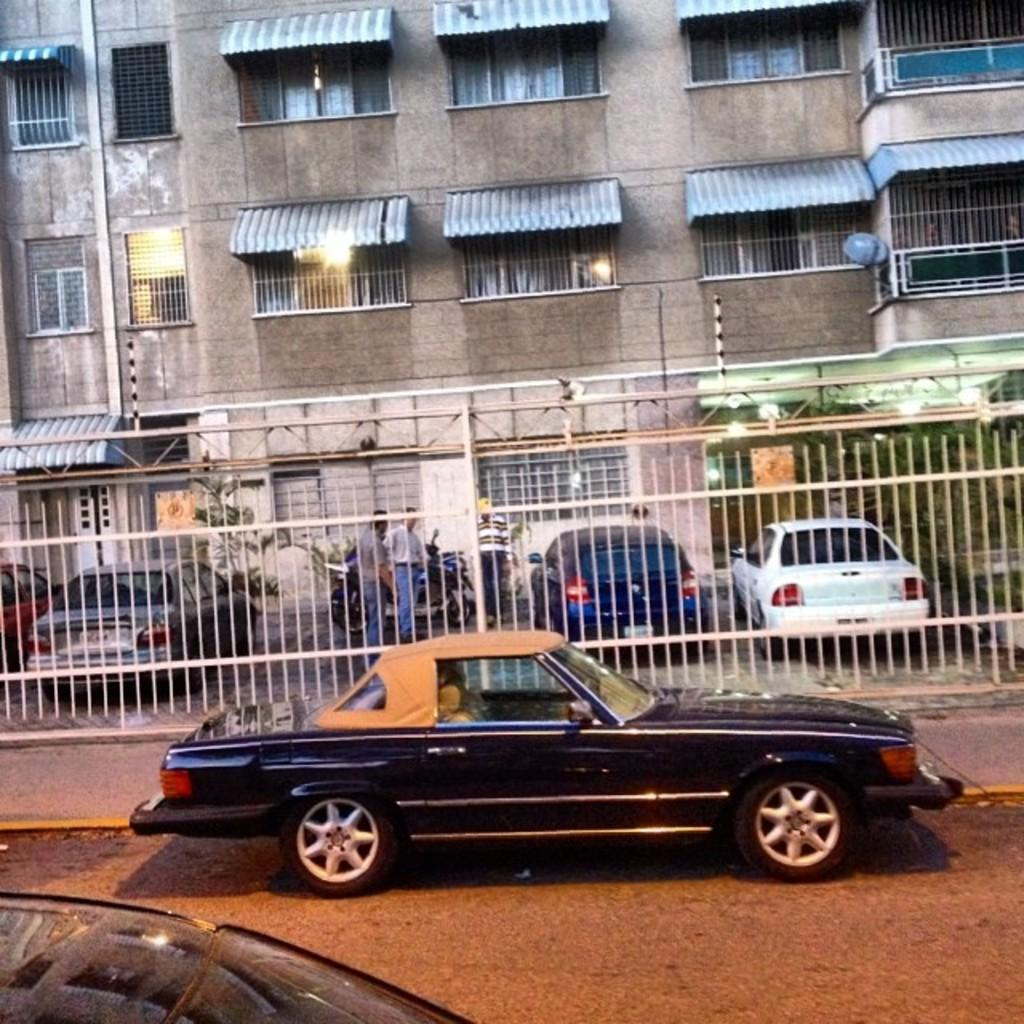What type of structure is present in the image? There is a building in the image. What features can be observed on the building? The building has windows and grilles. What other structure is visible in the image? There is a shed in the image. What else can be seen on the ground in the image? There are vehicles on the ground. What type of barrier is present in front of the building? There is a fence in front of the building. Can you tell me how much zinc is present in the building's structure? There is no information provided about the composition of the building's structure, so it is not possible to determine the amount of zinc present. 